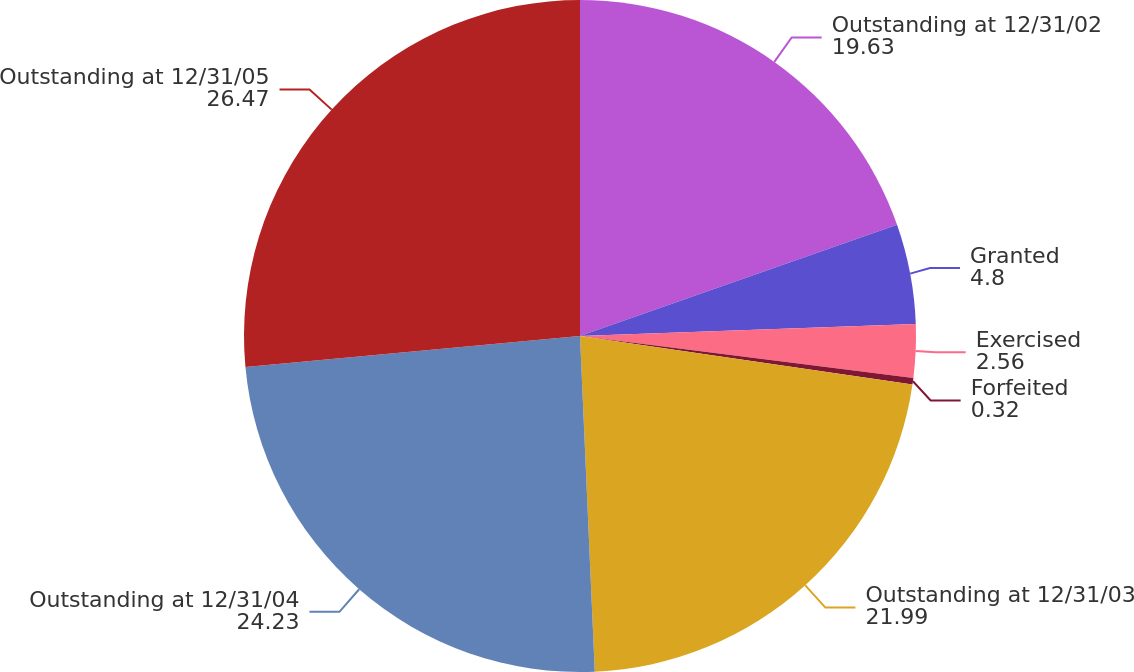<chart> <loc_0><loc_0><loc_500><loc_500><pie_chart><fcel>Outstanding at 12/31/02<fcel>Granted<fcel>Exercised<fcel>Forfeited<fcel>Outstanding at 12/31/03<fcel>Outstanding at 12/31/04<fcel>Outstanding at 12/31/05<nl><fcel>19.63%<fcel>4.8%<fcel>2.56%<fcel>0.32%<fcel>21.99%<fcel>24.23%<fcel>26.47%<nl></chart> 